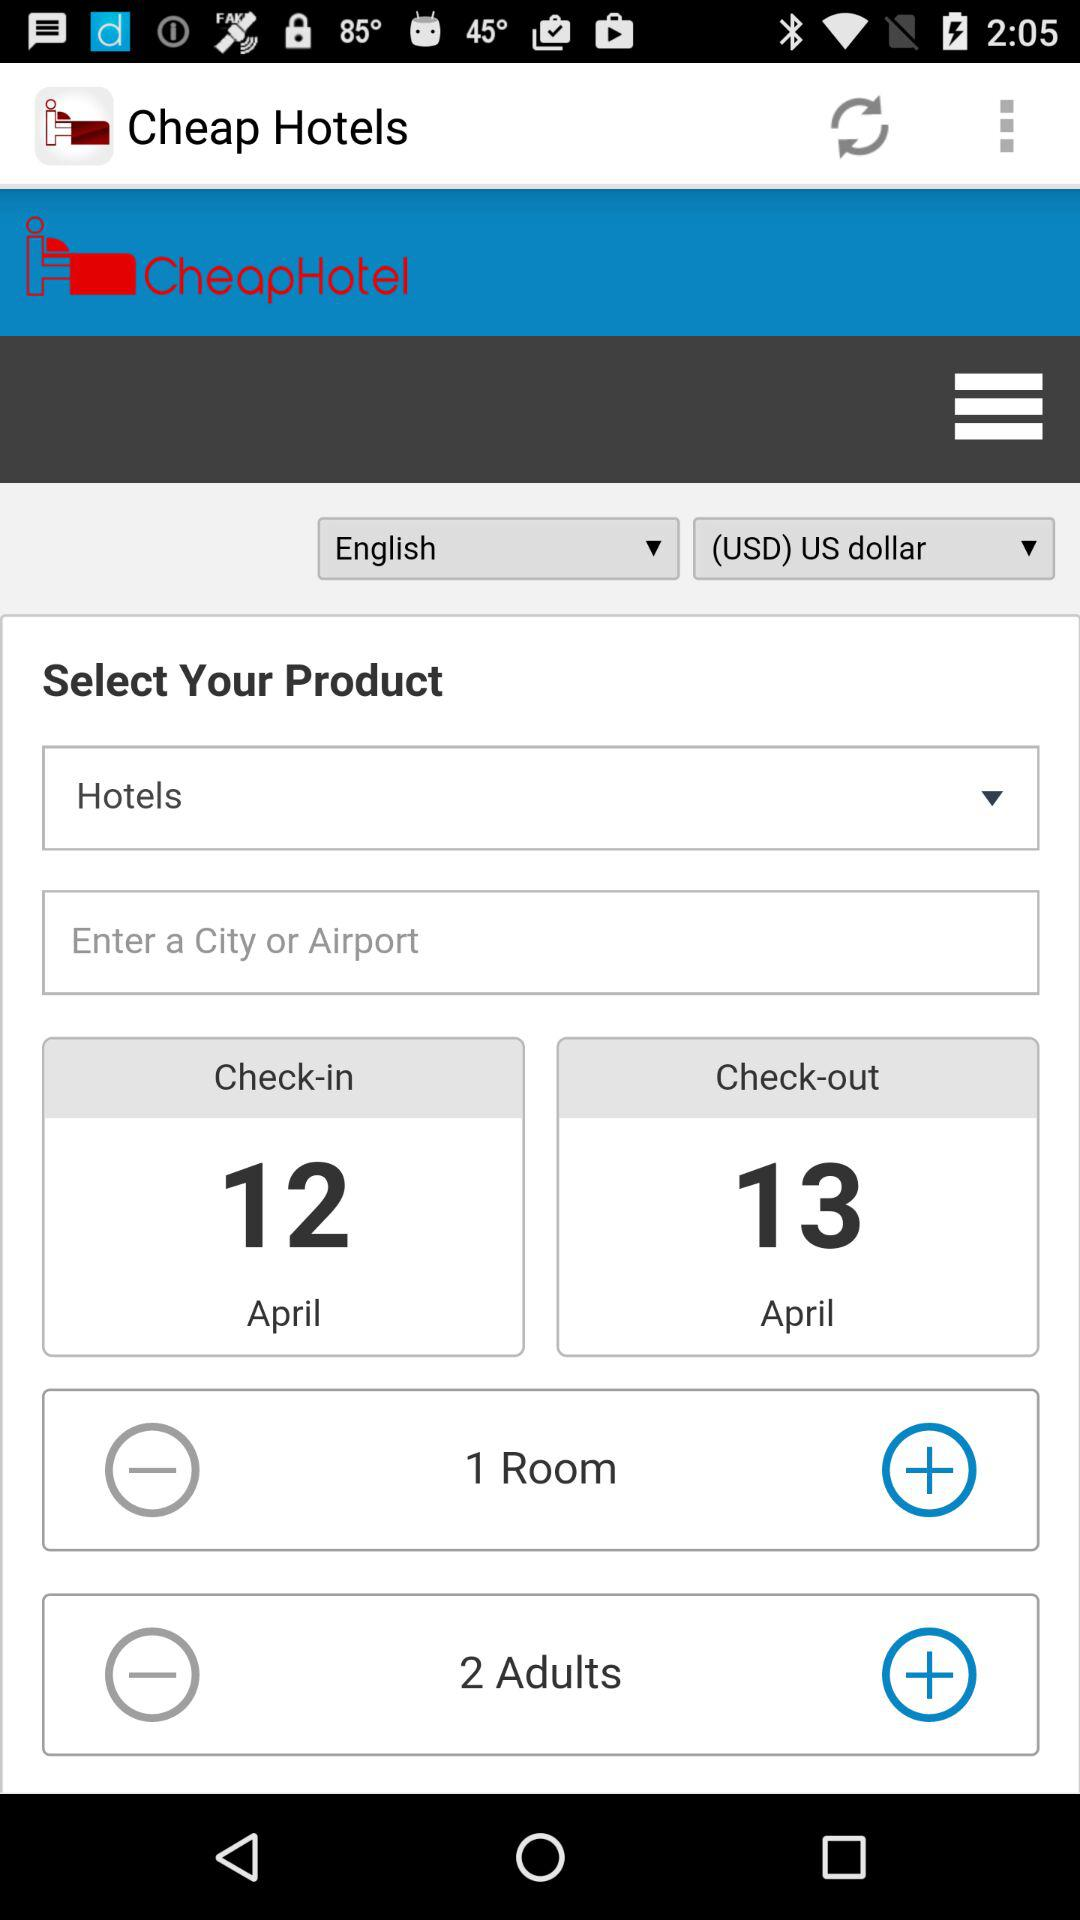How many rooms are selected for booking? There is 1 selected room. 